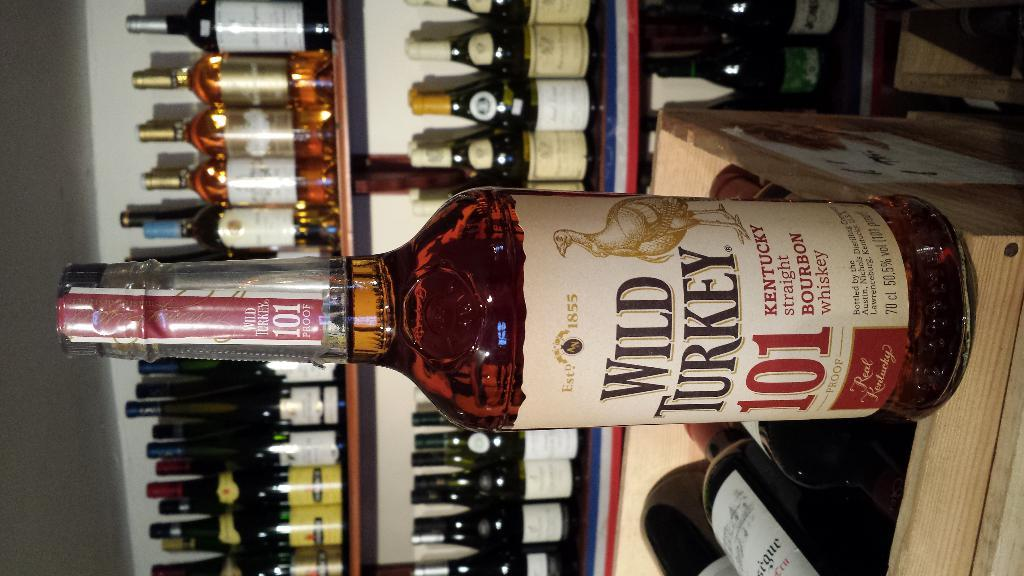What is inside the bottle in the image? The bottle is filled with liquid. Is there any additional information on the bottle? Yes, there is a sticker on the bottle. What is the container for the bottles in the image? The box contains bottles. How are the bottles arranged in the image? The rack is filled with bottles. What type of rabbit can be seen judging a backflip competition in the image? There is no rabbit or backflip competition present in the image. 